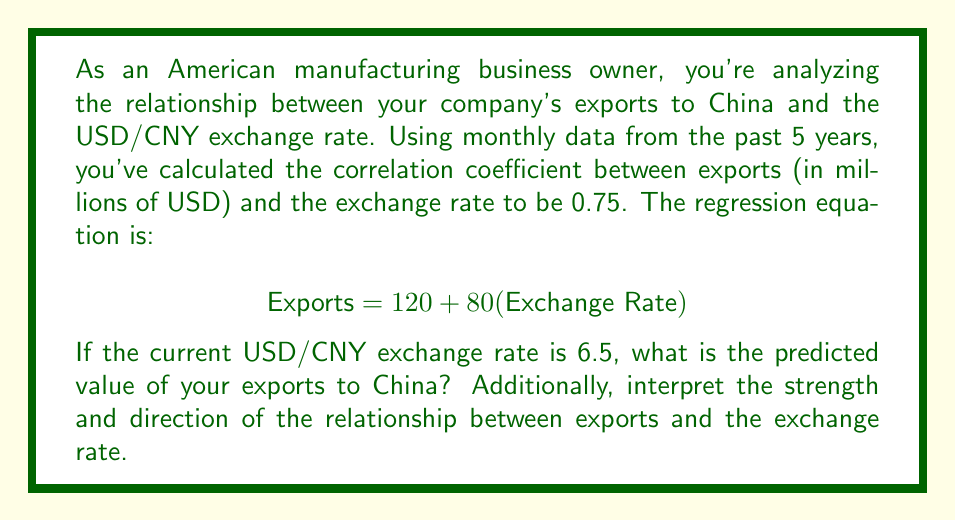Show me your answer to this math problem. 1. Understand the given information:
   - Correlation coefficient (r) = 0.75
   - Regression equation: $$ \text{Exports} = 120 + 80(\text{Exchange Rate}) $$
   - Current USD/CNY exchange rate = 6.5

2. Interpret the correlation coefficient:
   - r = 0.75 indicates a strong positive relationship between exports and exchange rate
   - The closer r is to 1, the stronger the positive relationship

3. Calculate the predicted exports using the regression equation:
   $$ \text{Exports} = 120 + 80(6.5) $$
   $$ \text{Exports} = 120 + 520 $$
   $$ \text{Exports} = 640 $$

4. Interpret the regression equation:
   - The y-intercept (120) represents the expected exports when the exchange rate is 0
   - The slope (80) indicates that for every 1 unit increase in the exchange rate, exports are expected to increase by 80 million USD

5. Summarize the relationship:
   - There is a strong positive relationship between exports and the USD/CNY exchange rate
   - As the exchange rate increases (USD strengthens relative to CNY), exports tend to increase
   - This relationship might be due to increased purchasing power of Chinese buyers when the USD is stronger
Answer: 640 million USD; strong positive relationship 